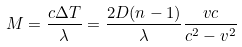<formula> <loc_0><loc_0><loc_500><loc_500>M = { \frac { c \Delta T } { \lambda } } = { \frac { 2 D ( n - 1 ) } { \lambda } } { \frac { v c } { { c ^ { 2 } - v ^ { 2 } } } }</formula> 